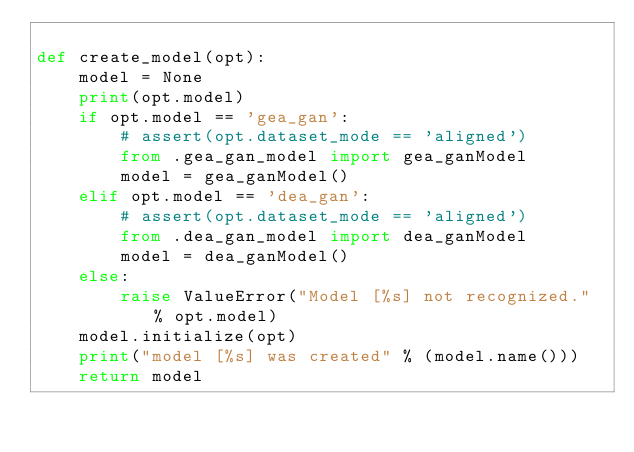Convert code to text. <code><loc_0><loc_0><loc_500><loc_500><_Python_>
def create_model(opt):
    model = None
    print(opt.model)
    if opt.model == 'gea_gan':
        # assert(opt.dataset_mode == 'aligned')
        from .gea_gan_model import gea_ganModel
        model = gea_ganModel()
    elif opt.model == 'dea_gan':
        # assert(opt.dataset_mode == 'aligned')
        from .dea_gan_model import dea_ganModel
        model = dea_ganModel()
    else:
        raise ValueError("Model [%s] not recognized." % opt.model)
    model.initialize(opt)
    print("model [%s] was created" % (model.name()))
    return model
</code> 